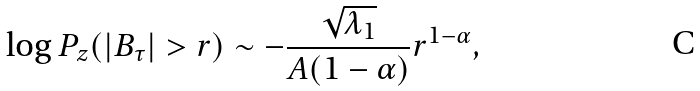Convert formula to latex. <formula><loc_0><loc_0><loc_500><loc_500>\log P _ { z } ( | B _ { \tau } | > r ) \sim - \frac { \sqrt { \lambda _ { 1 } } } { A ( 1 - \alpha ) } r ^ { 1 - \alpha } ,</formula> 